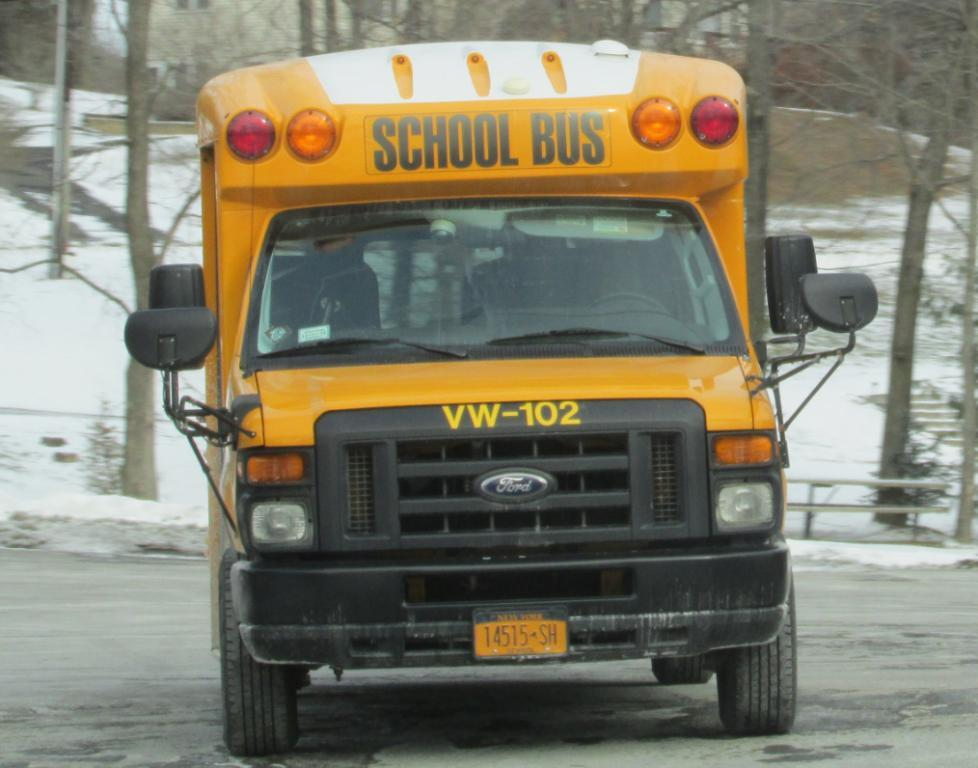What type of vehicle is in the image? There is a school bus in the image. What color is the school bus? The school bus is yellow. What can be seen in the background of the image? There are trees visible in the image. What is the weather like in the image? There is snow in the image, indicating a cold or wintry weather condition. Where is the place where the sugar is stored in the image? There is no mention of sugar or a place to store it in the image. Can you see any bears in the image? There are no bears present in the image. 